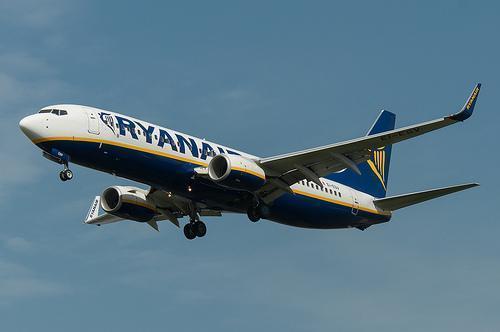How many planes are there?
Give a very brief answer. 1. How many wings are there?
Give a very brief answer. 2. 